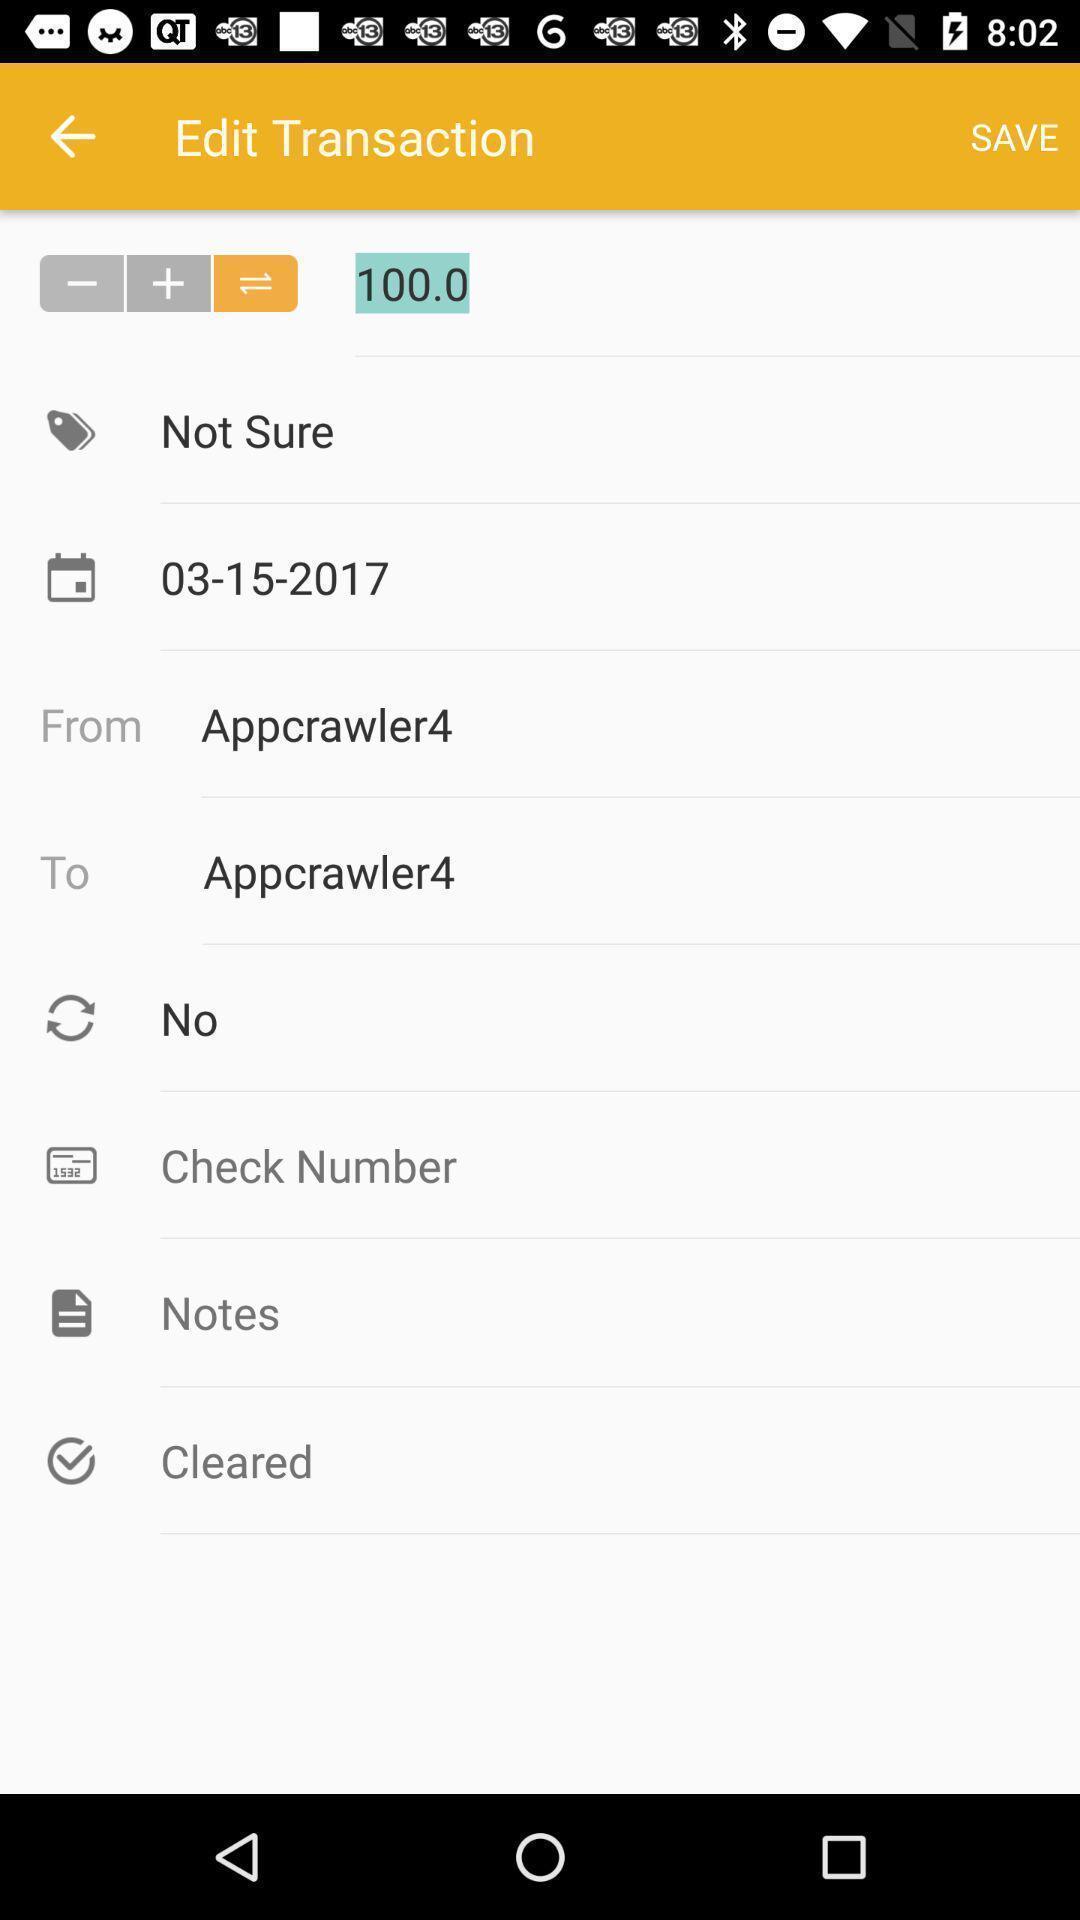What is the overall content of this screenshot? Screen displaying transaction editing page. 